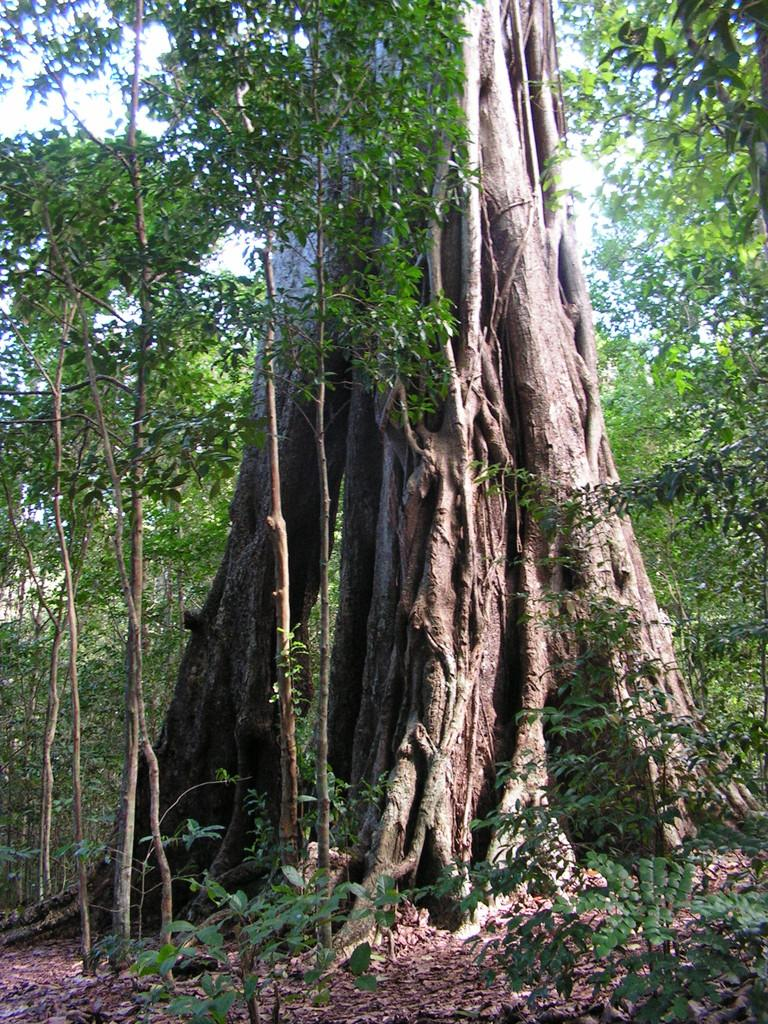What type of vegetation can be seen in the image? There are trees and plants in the image. What is the condition of the leaves on the trees and plants? Dry leaves are present in the image. What part of the natural environment is visible in the image? The sky is visible in the image. What type of plot can be seen being developed in the image? There is no plot or development project visible in the image; it features trees, plants, and dry leaves. What angle is the camera positioned at in the image? The angle of the camera is not mentioned in the provided facts, so it cannot be determined from the image. 